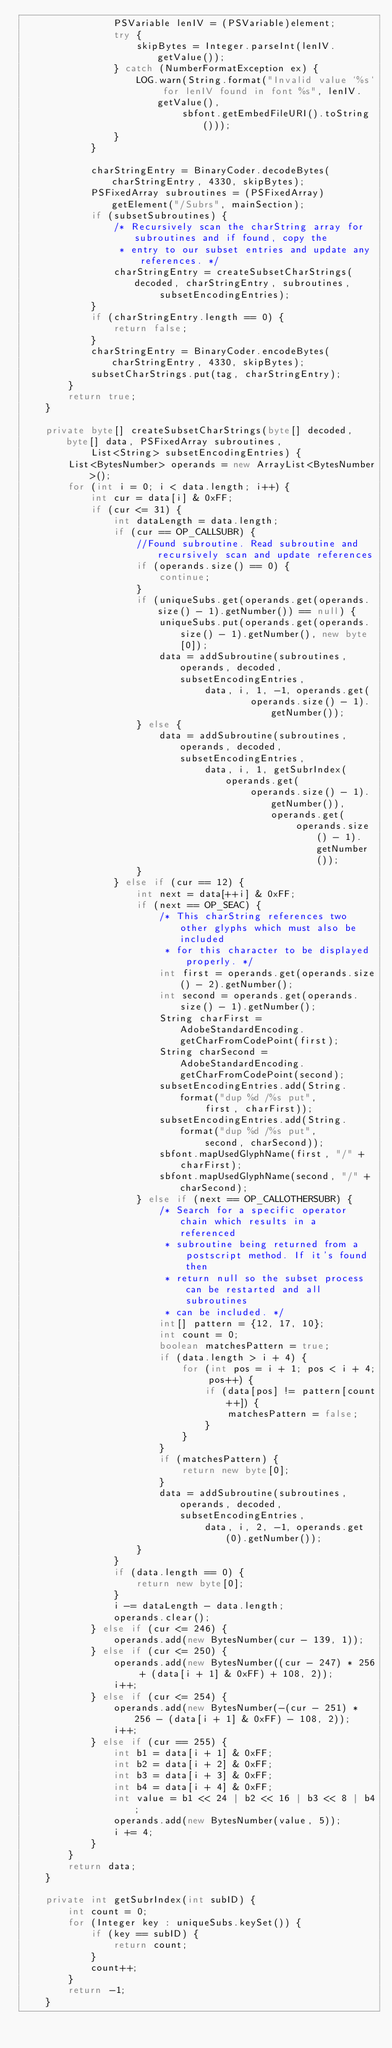Convert code to text. <code><loc_0><loc_0><loc_500><loc_500><_Java_>                PSVariable lenIV = (PSVariable)element;
                try {
                    skipBytes = Integer.parseInt(lenIV.getValue());
                } catch (NumberFormatException ex) {
                    LOG.warn(String.format("Invalid value `%s` for lenIV found in font %s", lenIV.getValue(),
                            sbfont.getEmbedFileURI().toString()));
                }
            }

            charStringEntry = BinaryCoder.decodeBytes(charStringEntry, 4330, skipBytes);
            PSFixedArray subroutines = (PSFixedArray)getElement("/Subrs", mainSection);
            if (subsetSubroutines) {
                /* Recursively scan the charString array for subroutines and if found, copy the
                 * entry to our subset entries and update any references. */
                charStringEntry = createSubsetCharStrings(decoded, charStringEntry, subroutines,
                        subsetEncodingEntries);
            }
            if (charStringEntry.length == 0) {
                return false;
            }
            charStringEntry = BinaryCoder.encodeBytes(charStringEntry, 4330, skipBytes);
            subsetCharStrings.put(tag, charStringEntry);
        }
        return true;
    }

    private byte[] createSubsetCharStrings(byte[] decoded, byte[] data, PSFixedArray subroutines,
            List<String> subsetEncodingEntries) {
        List<BytesNumber> operands = new ArrayList<BytesNumber>();
        for (int i = 0; i < data.length; i++) {
            int cur = data[i] & 0xFF;
            if (cur <= 31) {
                int dataLength = data.length;
                if (cur == OP_CALLSUBR) {
                    //Found subroutine. Read subroutine and recursively scan and update references
                    if (operands.size() == 0) {
                        continue;
                    }
                    if (uniqueSubs.get(operands.get(operands.size() - 1).getNumber()) == null) {
                        uniqueSubs.put(operands.get(operands.size() - 1).getNumber(), new byte[0]);
                        data = addSubroutine(subroutines, operands, decoded, subsetEncodingEntries,
                                data, i, 1, -1, operands.get(
                                        operands.size() - 1).getNumber());
                    } else {
                        data = addSubroutine(subroutines, operands, decoded, subsetEncodingEntries,
                                data, i, 1, getSubrIndex(operands.get(
                                        operands.size() - 1).getNumber()), operands.get(
                                                operands.size() - 1).getNumber());
                    }
                } else if (cur == 12) {
                    int next = data[++i] & 0xFF;
                    if (next == OP_SEAC) {
                        /* This charString references two other glyphs which must also be included
                         * for this character to be displayed properly. */
                        int first = operands.get(operands.size() - 2).getNumber();
                        int second = operands.get(operands.size() - 1).getNumber();
                        String charFirst = AdobeStandardEncoding.getCharFromCodePoint(first);
                        String charSecond = AdobeStandardEncoding.getCharFromCodePoint(second);
                        subsetEncodingEntries.add(String.format("dup %d /%s put",
                                first, charFirst));
                        subsetEncodingEntries.add(String.format("dup %d /%s put",
                                second, charSecond));
                        sbfont.mapUsedGlyphName(first, "/" + charFirst);
                        sbfont.mapUsedGlyphName(second, "/" + charSecond);
                    } else if (next == OP_CALLOTHERSUBR) {
                        /* Search for a specific operator chain which results in a referenced
                         * subroutine being returned from a postscript method. If it's found then
                         * return null so the subset process can be restarted and all subroutines
                         * can be included. */
                        int[] pattern = {12, 17, 10};
                        int count = 0;
                        boolean matchesPattern = true;
                        if (data.length > i + 4) {
                            for (int pos = i + 1; pos < i + 4; pos++) {
                                if (data[pos] != pattern[count++]) {
                                    matchesPattern = false;
                                }
                            }
                        }
                        if (matchesPattern) {
                            return new byte[0];
                        }
                        data = addSubroutine(subroutines, operands, decoded, subsetEncodingEntries,
                                data, i, 2, -1, operands.get(0).getNumber());
                    }
                }
                if (data.length == 0) {
                    return new byte[0];
                }
                i -= dataLength - data.length;
                operands.clear();
            } else if (cur <= 246) {
                operands.add(new BytesNumber(cur - 139, 1));
            } else if (cur <= 250) {
                operands.add(new BytesNumber((cur - 247) * 256 + (data[i + 1] & 0xFF) + 108, 2));
                i++;
            } else if (cur <= 254) {
                operands.add(new BytesNumber(-(cur - 251) * 256 - (data[i + 1] & 0xFF) - 108, 2));
                i++;
            } else if (cur == 255) {
                int b1 = data[i + 1] & 0xFF;
                int b2 = data[i + 2] & 0xFF;
                int b3 = data[i + 3] & 0xFF;
                int b4 = data[i + 4] & 0xFF;
                int value = b1 << 24 | b2 << 16 | b3 << 8 | b4;
                operands.add(new BytesNumber(value, 5));
                i += 4;
            }
        }
        return data;
    }

    private int getSubrIndex(int subID) {
        int count = 0;
        for (Integer key : uniqueSubs.keySet()) {
            if (key == subID) {
                return count;
            }
            count++;
        }
        return -1;
    }
</code> 